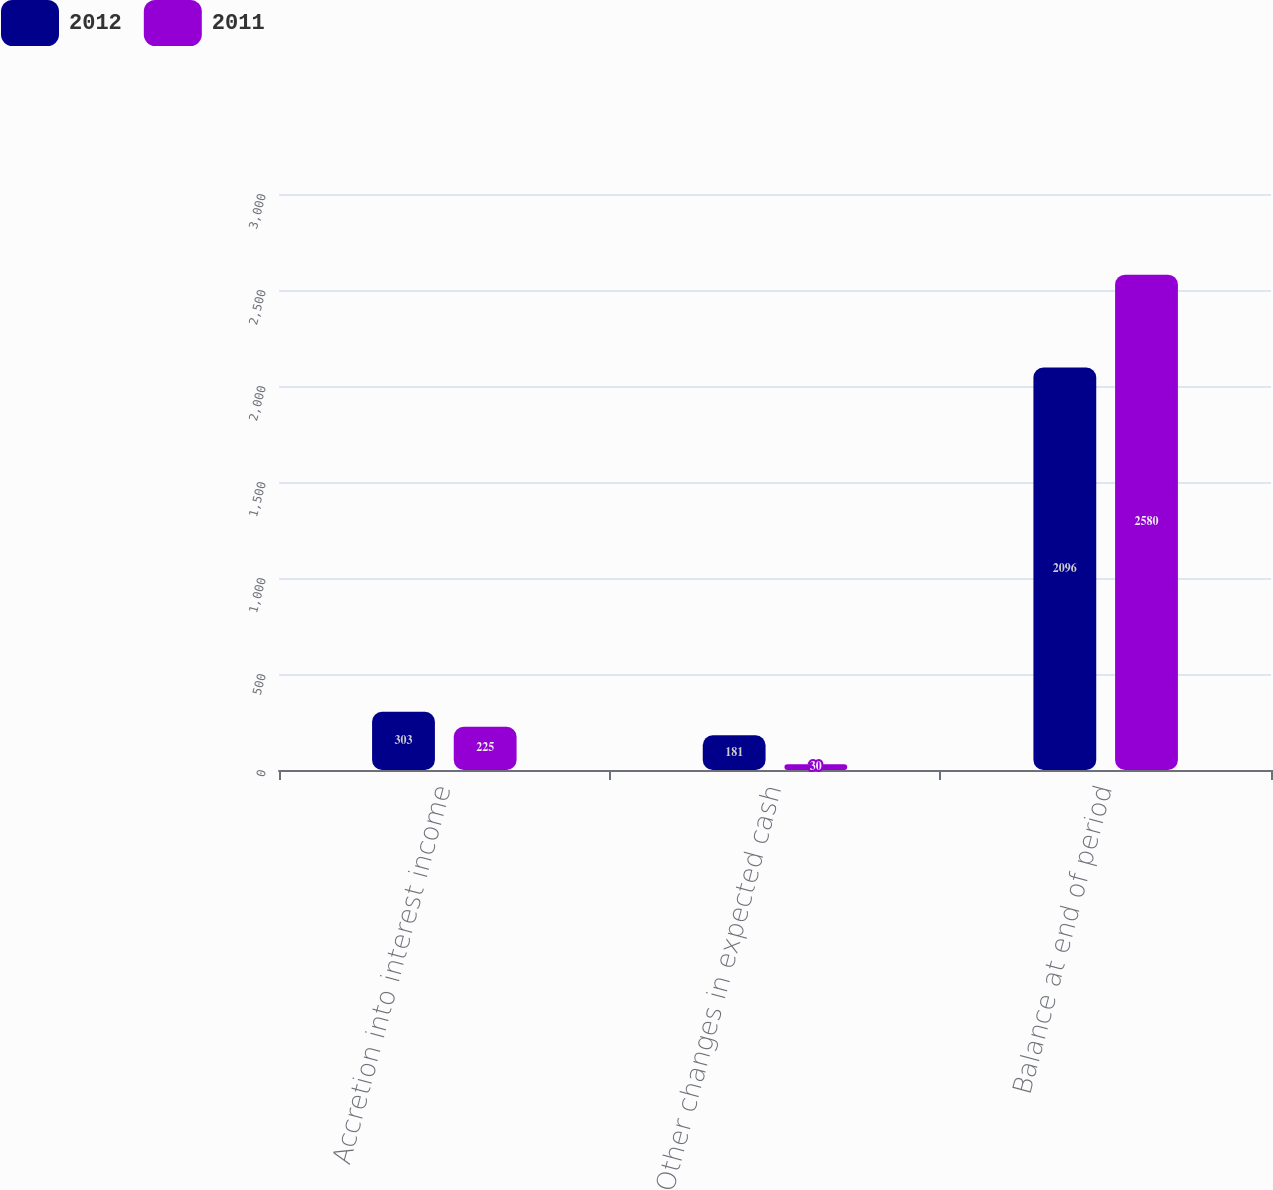Convert chart to OTSL. <chart><loc_0><loc_0><loc_500><loc_500><stacked_bar_chart><ecel><fcel>Accretion into interest income<fcel>Other changes in expected cash<fcel>Balance at end of period<nl><fcel>2012<fcel>303<fcel>181<fcel>2096<nl><fcel>2011<fcel>225<fcel>30<fcel>2580<nl></chart> 